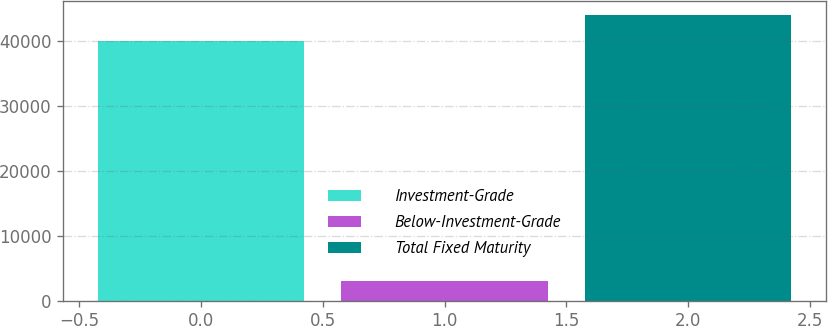<chart> <loc_0><loc_0><loc_500><loc_500><bar_chart><fcel>Investment-Grade<fcel>Below-Investment-Grade<fcel>Total Fixed Maturity<nl><fcel>39973.1<fcel>3038.6<fcel>43970.4<nl></chart> 